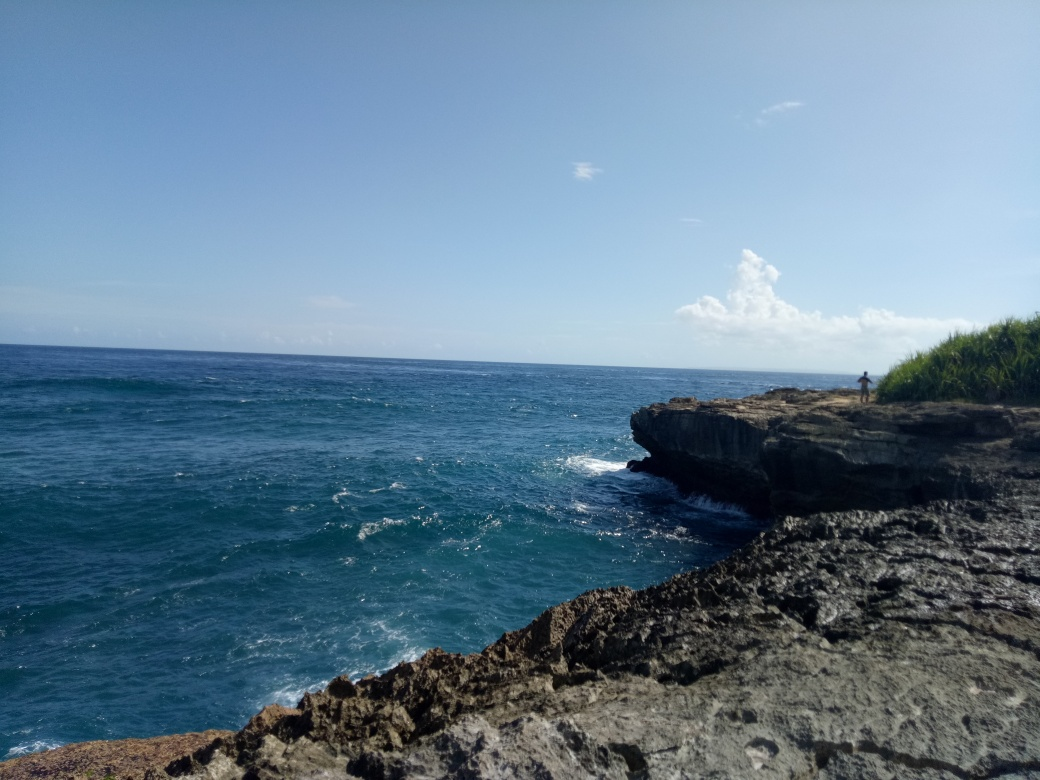Is the image of high quality?
 Yes 